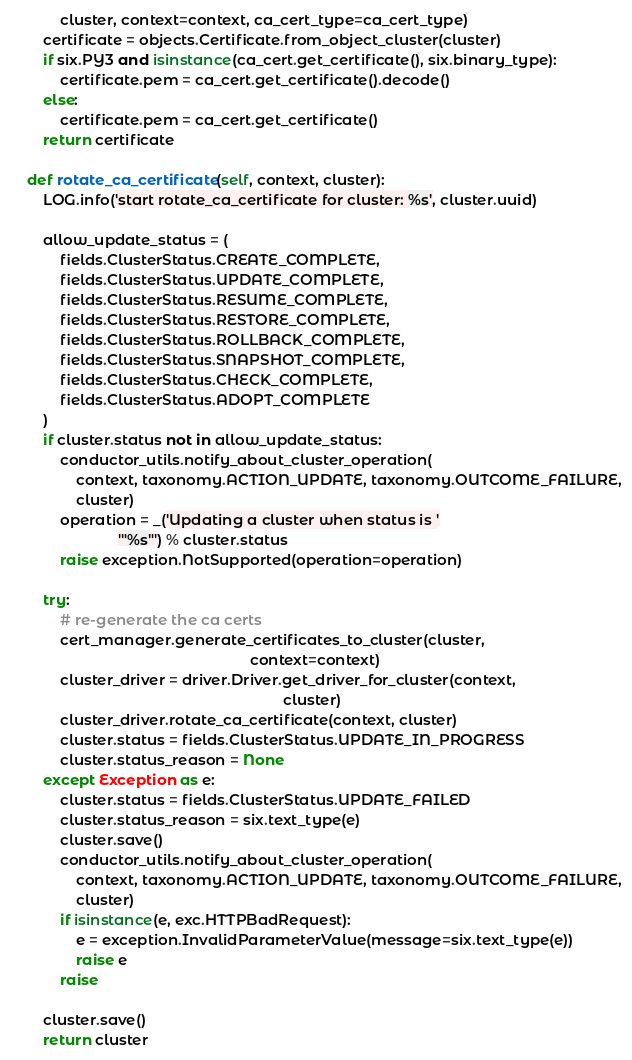<code> <loc_0><loc_0><loc_500><loc_500><_Python_>            cluster, context=context, ca_cert_type=ca_cert_type)
        certificate = objects.Certificate.from_object_cluster(cluster)
        if six.PY3 and isinstance(ca_cert.get_certificate(), six.binary_type):
            certificate.pem = ca_cert.get_certificate().decode()
        else:
            certificate.pem = ca_cert.get_certificate()
        return certificate

    def rotate_ca_certificate(self, context, cluster):
        LOG.info('start rotate_ca_certificate for cluster: %s', cluster.uuid)

        allow_update_status = (
            fields.ClusterStatus.CREATE_COMPLETE,
            fields.ClusterStatus.UPDATE_COMPLETE,
            fields.ClusterStatus.RESUME_COMPLETE,
            fields.ClusterStatus.RESTORE_COMPLETE,
            fields.ClusterStatus.ROLLBACK_COMPLETE,
            fields.ClusterStatus.SNAPSHOT_COMPLETE,
            fields.ClusterStatus.CHECK_COMPLETE,
            fields.ClusterStatus.ADOPT_COMPLETE
        )
        if cluster.status not in allow_update_status:
            conductor_utils.notify_about_cluster_operation(
                context, taxonomy.ACTION_UPDATE, taxonomy.OUTCOME_FAILURE,
                cluster)
            operation = _('Updating a cluster when status is '
                          '"%s"') % cluster.status
            raise exception.NotSupported(operation=operation)

        try:
            # re-generate the ca certs
            cert_manager.generate_certificates_to_cluster(cluster,
                                                          context=context)
            cluster_driver = driver.Driver.get_driver_for_cluster(context,
                                                                  cluster)
            cluster_driver.rotate_ca_certificate(context, cluster)
            cluster.status = fields.ClusterStatus.UPDATE_IN_PROGRESS
            cluster.status_reason = None
        except Exception as e:
            cluster.status = fields.ClusterStatus.UPDATE_FAILED
            cluster.status_reason = six.text_type(e)
            cluster.save()
            conductor_utils.notify_about_cluster_operation(
                context, taxonomy.ACTION_UPDATE, taxonomy.OUTCOME_FAILURE,
                cluster)
            if isinstance(e, exc.HTTPBadRequest):
                e = exception.InvalidParameterValue(message=six.text_type(e))
                raise e
            raise

        cluster.save()
        return cluster
</code> 